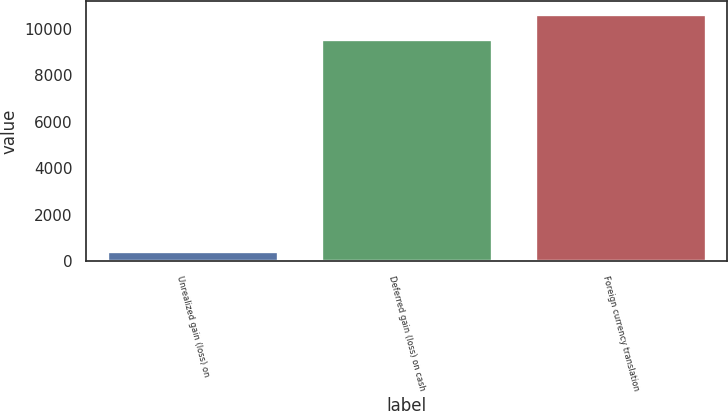<chart> <loc_0><loc_0><loc_500><loc_500><bar_chart><fcel>Unrealized gain (loss) on<fcel>Deferred gain (loss) on cash<fcel>Foreign currency translation<nl><fcel>443<fcel>9550<fcel>10638<nl></chart> 